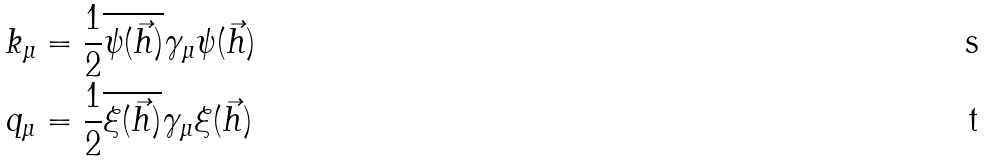Convert formula to latex. <formula><loc_0><loc_0><loc_500><loc_500>k _ { \mu } & = \frac { 1 } { 2 } \overline { \psi ( \vec { h } ) } \gamma _ { \mu } \psi ( \vec { h } ) \\ q _ { \mu } & = \frac { 1 } { 2 } \overline { \xi ( \vec { h } ) } \gamma _ { \mu } \xi ( \vec { h } )</formula> 